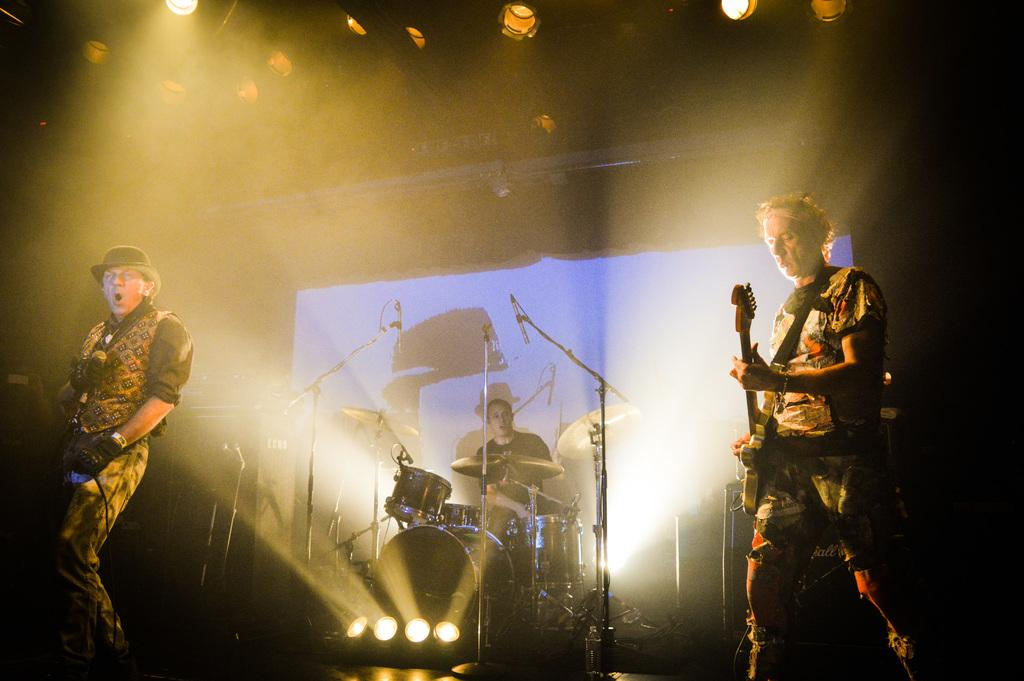What is the man in the foreground of the image holding? The man in the foreground of the image is holding a mic. What is the man next to him holding? The man next to him is holding a guitar. Can you describe the third man in the image? There is a man with drums in the background of the image. What can be seen in the image that provides illumination? There are lights visible in the image. What type of owl can be seen perched on the guitar in the image? There is no owl present in the image; the man is holding a guitar, but there is no owl on it. 